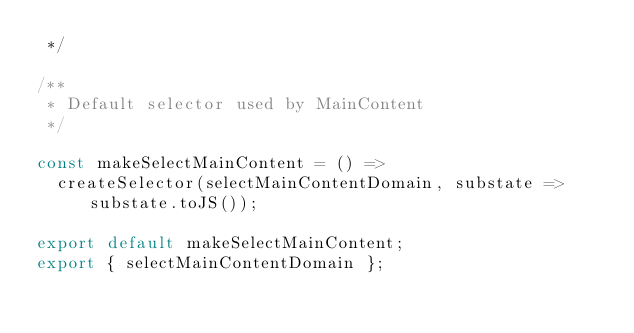Convert code to text. <code><loc_0><loc_0><loc_500><loc_500><_JavaScript_> */

/**
 * Default selector used by MainContent
 */

const makeSelectMainContent = () =>
  createSelector(selectMainContentDomain, substate => substate.toJS());

export default makeSelectMainContent;
export { selectMainContentDomain };
</code> 